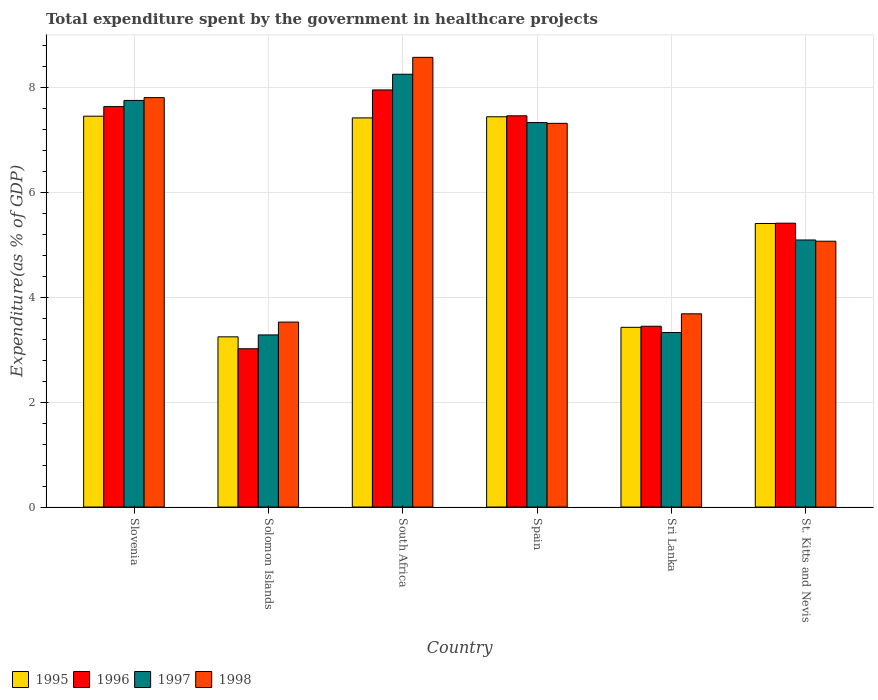How many bars are there on the 6th tick from the left?
Your answer should be very brief. 4. How many bars are there on the 6th tick from the right?
Provide a short and direct response. 4. What is the total expenditure spent by the government in healthcare projects in 1995 in St. Kitts and Nevis?
Provide a short and direct response. 5.41. Across all countries, what is the maximum total expenditure spent by the government in healthcare projects in 1997?
Your answer should be very brief. 8.26. Across all countries, what is the minimum total expenditure spent by the government in healthcare projects in 1996?
Offer a terse response. 3.02. In which country was the total expenditure spent by the government in healthcare projects in 1997 maximum?
Keep it short and to the point. South Africa. In which country was the total expenditure spent by the government in healthcare projects in 1998 minimum?
Your answer should be compact. Solomon Islands. What is the total total expenditure spent by the government in healthcare projects in 1997 in the graph?
Your answer should be very brief. 35.05. What is the difference between the total expenditure spent by the government in healthcare projects in 1997 in Solomon Islands and that in St. Kitts and Nevis?
Keep it short and to the point. -1.81. What is the difference between the total expenditure spent by the government in healthcare projects in 1996 in South Africa and the total expenditure spent by the government in healthcare projects in 1998 in Solomon Islands?
Provide a short and direct response. 4.43. What is the average total expenditure spent by the government in healthcare projects in 1996 per country?
Your answer should be very brief. 5.82. What is the difference between the total expenditure spent by the government in healthcare projects of/in 1995 and total expenditure spent by the government in healthcare projects of/in 1997 in Sri Lanka?
Make the answer very short. 0.1. In how many countries, is the total expenditure spent by the government in healthcare projects in 1998 greater than 0.8 %?
Your answer should be compact. 6. What is the ratio of the total expenditure spent by the government in healthcare projects in 1997 in South Africa to that in St. Kitts and Nevis?
Ensure brevity in your answer.  1.62. Is the total expenditure spent by the government in healthcare projects in 1997 in Slovenia less than that in South Africa?
Offer a terse response. Yes. What is the difference between the highest and the second highest total expenditure spent by the government in healthcare projects in 1996?
Your answer should be very brief. 0.18. What is the difference between the highest and the lowest total expenditure spent by the government in healthcare projects in 1995?
Offer a very short reply. 4.21. What does the 2nd bar from the right in St. Kitts and Nevis represents?
Provide a succinct answer. 1997. Is it the case that in every country, the sum of the total expenditure spent by the government in healthcare projects in 1998 and total expenditure spent by the government in healthcare projects in 1997 is greater than the total expenditure spent by the government in healthcare projects in 1995?
Your response must be concise. Yes. How many bars are there?
Make the answer very short. 24. How many countries are there in the graph?
Provide a succinct answer. 6. What is the difference between two consecutive major ticks on the Y-axis?
Make the answer very short. 2. Are the values on the major ticks of Y-axis written in scientific E-notation?
Your answer should be very brief. No. Does the graph contain any zero values?
Your answer should be very brief. No. Does the graph contain grids?
Your answer should be compact. Yes. Where does the legend appear in the graph?
Provide a succinct answer. Bottom left. How many legend labels are there?
Your answer should be compact. 4. How are the legend labels stacked?
Your answer should be compact. Horizontal. What is the title of the graph?
Your response must be concise. Total expenditure spent by the government in healthcare projects. What is the label or title of the Y-axis?
Your answer should be compact. Expenditure(as % of GDP). What is the Expenditure(as % of GDP) in 1995 in Slovenia?
Keep it short and to the point. 7.46. What is the Expenditure(as % of GDP) in 1996 in Slovenia?
Offer a very short reply. 7.64. What is the Expenditure(as % of GDP) in 1997 in Slovenia?
Offer a very short reply. 7.76. What is the Expenditure(as % of GDP) in 1998 in Slovenia?
Your response must be concise. 7.81. What is the Expenditure(as % of GDP) in 1995 in Solomon Islands?
Your response must be concise. 3.25. What is the Expenditure(as % of GDP) in 1996 in Solomon Islands?
Your answer should be compact. 3.02. What is the Expenditure(as % of GDP) of 1997 in Solomon Islands?
Keep it short and to the point. 3.28. What is the Expenditure(as % of GDP) in 1998 in Solomon Islands?
Your answer should be very brief. 3.53. What is the Expenditure(as % of GDP) of 1995 in South Africa?
Ensure brevity in your answer.  7.42. What is the Expenditure(as % of GDP) of 1996 in South Africa?
Provide a short and direct response. 7.96. What is the Expenditure(as % of GDP) of 1997 in South Africa?
Your response must be concise. 8.26. What is the Expenditure(as % of GDP) in 1998 in South Africa?
Your answer should be compact. 8.58. What is the Expenditure(as % of GDP) of 1995 in Spain?
Keep it short and to the point. 7.44. What is the Expenditure(as % of GDP) in 1996 in Spain?
Offer a very short reply. 7.46. What is the Expenditure(as % of GDP) in 1997 in Spain?
Your answer should be very brief. 7.33. What is the Expenditure(as % of GDP) in 1998 in Spain?
Your answer should be compact. 7.32. What is the Expenditure(as % of GDP) of 1995 in Sri Lanka?
Your answer should be compact. 3.43. What is the Expenditure(as % of GDP) of 1996 in Sri Lanka?
Your response must be concise. 3.45. What is the Expenditure(as % of GDP) in 1997 in Sri Lanka?
Your response must be concise. 3.33. What is the Expenditure(as % of GDP) in 1998 in Sri Lanka?
Offer a very short reply. 3.69. What is the Expenditure(as % of GDP) of 1995 in St. Kitts and Nevis?
Make the answer very short. 5.41. What is the Expenditure(as % of GDP) of 1996 in St. Kitts and Nevis?
Your response must be concise. 5.41. What is the Expenditure(as % of GDP) in 1997 in St. Kitts and Nevis?
Keep it short and to the point. 5.09. What is the Expenditure(as % of GDP) in 1998 in St. Kitts and Nevis?
Give a very brief answer. 5.07. Across all countries, what is the maximum Expenditure(as % of GDP) in 1995?
Make the answer very short. 7.46. Across all countries, what is the maximum Expenditure(as % of GDP) of 1996?
Keep it short and to the point. 7.96. Across all countries, what is the maximum Expenditure(as % of GDP) of 1997?
Your response must be concise. 8.26. Across all countries, what is the maximum Expenditure(as % of GDP) of 1998?
Your answer should be compact. 8.58. Across all countries, what is the minimum Expenditure(as % of GDP) in 1995?
Your response must be concise. 3.25. Across all countries, what is the minimum Expenditure(as % of GDP) of 1996?
Provide a succinct answer. 3.02. Across all countries, what is the minimum Expenditure(as % of GDP) of 1997?
Your answer should be compact. 3.28. Across all countries, what is the minimum Expenditure(as % of GDP) of 1998?
Provide a succinct answer. 3.53. What is the total Expenditure(as % of GDP) of 1995 in the graph?
Offer a very short reply. 34.41. What is the total Expenditure(as % of GDP) in 1996 in the graph?
Your answer should be compact. 34.94. What is the total Expenditure(as % of GDP) in 1997 in the graph?
Make the answer very short. 35.05. What is the total Expenditure(as % of GDP) of 1998 in the graph?
Offer a very short reply. 35.99. What is the difference between the Expenditure(as % of GDP) of 1995 in Slovenia and that in Solomon Islands?
Offer a very short reply. 4.21. What is the difference between the Expenditure(as % of GDP) of 1996 in Slovenia and that in Solomon Islands?
Offer a terse response. 4.62. What is the difference between the Expenditure(as % of GDP) of 1997 in Slovenia and that in Solomon Islands?
Provide a succinct answer. 4.47. What is the difference between the Expenditure(as % of GDP) of 1998 in Slovenia and that in Solomon Islands?
Your response must be concise. 4.28. What is the difference between the Expenditure(as % of GDP) in 1995 in Slovenia and that in South Africa?
Keep it short and to the point. 0.03. What is the difference between the Expenditure(as % of GDP) of 1996 in Slovenia and that in South Africa?
Make the answer very short. -0.32. What is the difference between the Expenditure(as % of GDP) of 1997 in Slovenia and that in South Africa?
Provide a short and direct response. -0.5. What is the difference between the Expenditure(as % of GDP) in 1998 in Slovenia and that in South Africa?
Ensure brevity in your answer.  -0.77. What is the difference between the Expenditure(as % of GDP) in 1995 in Slovenia and that in Spain?
Your response must be concise. 0.01. What is the difference between the Expenditure(as % of GDP) of 1996 in Slovenia and that in Spain?
Your answer should be compact. 0.18. What is the difference between the Expenditure(as % of GDP) of 1997 in Slovenia and that in Spain?
Keep it short and to the point. 0.42. What is the difference between the Expenditure(as % of GDP) of 1998 in Slovenia and that in Spain?
Ensure brevity in your answer.  0.49. What is the difference between the Expenditure(as % of GDP) of 1995 in Slovenia and that in Sri Lanka?
Offer a terse response. 4.03. What is the difference between the Expenditure(as % of GDP) of 1996 in Slovenia and that in Sri Lanka?
Your answer should be very brief. 4.19. What is the difference between the Expenditure(as % of GDP) of 1997 in Slovenia and that in Sri Lanka?
Your answer should be very brief. 4.43. What is the difference between the Expenditure(as % of GDP) of 1998 in Slovenia and that in Sri Lanka?
Your answer should be very brief. 4.12. What is the difference between the Expenditure(as % of GDP) in 1995 in Slovenia and that in St. Kitts and Nevis?
Offer a terse response. 2.05. What is the difference between the Expenditure(as % of GDP) of 1996 in Slovenia and that in St. Kitts and Nevis?
Provide a succinct answer. 2.22. What is the difference between the Expenditure(as % of GDP) in 1997 in Slovenia and that in St. Kitts and Nevis?
Make the answer very short. 2.66. What is the difference between the Expenditure(as % of GDP) in 1998 in Slovenia and that in St. Kitts and Nevis?
Your answer should be compact. 2.74. What is the difference between the Expenditure(as % of GDP) in 1995 in Solomon Islands and that in South Africa?
Provide a succinct answer. -4.18. What is the difference between the Expenditure(as % of GDP) in 1996 in Solomon Islands and that in South Africa?
Your answer should be very brief. -4.94. What is the difference between the Expenditure(as % of GDP) of 1997 in Solomon Islands and that in South Africa?
Provide a succinct answer. -4.97. What is the difference between the Expenditure(as % of GDP) of 1998 in Solomon Islands and that in South Africa?
Give a very brief answer. -5.05. What is the difference between the Expenditure(as % of GDP) in 1995 in Solomon Islands and that in Spain?
Provide a succinct answer. -4.2. What is the difference between the Expenditure(as % of GDP) of 1996 in Solomon Islands and that in Spain?
Give a very brief answer. -4.44. What is the difference between the Expenditure(as % of GDP) in 1997 in Solomon Islands and that in Spain?
Make the answer very short. -4.05. What is the difference between the Expenditure(as % of GDP) in 1998 in Solomon Islands and that in Spain?
Give a very brief answer. -3.79. What is the difference between the Expenditure(as % of GDP) in 1995 in Solomon Islands and that in Sri Lanka?
Keep it short and to the point. -0.18. What is the difference between the Expenditure(as % of GDP) in 1996 in Solomon Islands and that in Sri Lanka?
Keep it short and to the point. -0.43. What is the difference between the Expenditure(as % of GDP) in 1997 in Solomon Islands and that in Sri Lanka?
Keep it short and to the point. -0.05. What is the difference between the Expenditure(as % of GDP) of 1998 in Solomon Islands and that in Sri Lanka?
Offer a terse response. -0.16. What is the difference between the Expenditure(as % of GDP) of 1995 in Solomon Islands and that in St. Kitts and Nevis?
Offer a very short reply. -2.16. What is the difference between the Expenditure(as % of GDP) of 1996 in Solomon Islands and that in St. Kitts and Nevis?
Provide a short and direct response. -2.4. What is the difference between the Expenditure(as % of GDP) in 1997 in Solomon Islands and that in St. Kitts and Nevis?
Your answer should be very brief. -1.81. What is the difference between the Expenditure(as % of GDP) in 1998 in Solomon Islands and that in St. Kitts and Nevis?
Give a very brief answer. -1.54. What is the difference between the Expenditure(as % of GDP) in 1995 in South Africa and that in Spain?
Offer a terse response. -0.02. What is the difference between the Expenditure(as % of GDP) in 1996 in South Africa and that in Spain?
Provide a succinct answer. 0.49. What is the difference between the Expenditure(as % of GDP) of 1997 in South Africa and that in Spain?
Keep it short and to the point. 0.92. What is the difference between the Expenditure(as % of GDP) in 1998 in South Africa and that in Spain?
Offer a very short reply. 1.26. What is the difference between the Expenditure(as % of GDP) of 1995 in South Africa and that in Sri Lanka?
Your answer should be very brief. 3.99. What is the difference between the Expenditure(as % of GDP) in 1996 in South Africa and that in Sri Lanka?
Your response must be concise. 4.51. What is the difference between the Expenditure(as % of GDP) of 1997 in South Africa and that in Sri Lanka?
Provide a short and direct response. 4.93. What is the difference between the Expenditure(as % of GDP) in 1998 in South Africa and that in Sri Lanka?
Keep it short and to the point. 4.89. What is the difference between the Expenditure(as % of GDP) in 1995 in South Africa and that in St. Kitts and Nevis?
Make the answer very short. 2.01. What is the difference between the Expenditure(as % of GDP) of 1996 in South Africa and that in St. Kitts and Nevis?
Give a very brief answer. 2.54. What is the difference between the Expenditure(as % of GDP) in 1997 in South Africa and that in St. Kitts and Nevis?
Make the answer very short. 3.16. What is the difference between the Expenditure(as % of GDP) of 1998 in South Africa and that in St. Kitts and Nevis?
Offer a terse response. 3.51. What is the difference between the Expenditure(as % of GDP) of 1995 in Spain and that in Sri Lanka?
Your answer should be very brief. 4.02. What is the difference between the Expenditure(as % of GDP) in 1996 in Spain and that in Sri Lanka?
Make the answer very short. 4.01. What is the difference between the Expenditure(as % of GDP) in 1997 in Spain and that in Sri Lanka?
Ensure brevity in your answer.  4. What is the difference between the Expenditure(as % of GDP) of 1998 in Spain and that in Sri Lanka?
Your answer should be very brief. 3.63. What is the difference between the Expenditure(as % of GDP) of 1995 in Spain and that in St. Kitts and Nevis?
Offer a very short reply. 2.04. What is the difference between the Expenditure(as % of GDP) of 1996 in Spain and that in St. Kitts and Nevis?
Your answer should be very brief. 2.05. What is the difference between the Expenditure(as % of GDP) in 1997 in Spain and that in St. Kitts and Nevis?
Your answer should be very brief. 2.24. What is the difference between the Expenditure(as % of GDP) of 1998 in Spain and that in St. Kitts and Nevis?
Offer a very short reply. 2.25. What is the difference between the Expenditure(as % of GDP) in 1995 in Sri Lanka and that in St. Kitts and Nevis?
Give a very brief answer. -1.98. What is the difference between the Expenditure(as % of GDP) of 1996 in Sri Lanka and that in St. Kitts and Nevis?
Keep it short and to the point. -1.97. What is the difference between the Expenditure(as % of GDP) of 1997 in Sri Lanka and that in St. Kitts and Nevis?
Provide a short and direct response. -1.76. What is the difference between the Expenditure(as % of GDP) in 1998 in Sri Lanka and that in St. Kitts and Nevis?
Provide a succinct answer. -1.39. What is the difference between the Expenditure(as % of GDP) of 1995 in Slovenia and the Expenditure(as % of GDP) of 1996 in Solomon Islands?
Your answer should be very brief. 4.44. What is the difference between the Expenditure(as % of GDP) in 1995 in Slovenia and the Expenditure(as % of GDP) in 1997 in Solomon Islands?
Provide a short and direct response. 4.17. What is the difference between the Expenditure(as % of GDP) in 1995 in Slovenia and the Expenditure(as % of GDP) in 1998 in Solomon Islands?
Your answer should be compact. 3.93. What is the difference between the Expenditure(as % of GDP) in 1996 in Slovenia and the Expenditure(as % of GDP) in 1997 in Solomon Islands?
Your answer should be very brief. 4.36. What is the difference between the Expenditure(as % of GDP) in 1996 in Slovenia and the Expenditure(as % of GDP) in 1998 in Solomon Islands?
Give a very brief answer. 4.11. What is the difference between the Expenditure(as % of GDP) in 1997 in Slovenia and the Expenditure(as % of GDP) in 1998 in Solomon Islands?
Your answer should be very brief. 4.23. What is the difference between the Expenditure(as % of GDP) of 1995 in Slovenia and the Expenditure(as % of GDP) of 1996 in South Africa?
Your answer should be compact. -0.5. What is the difference between the Expenditure(as % of GDP) of 1995 in Slovenia and the Expenditure(as % of GDP) of 1997 in South Africa?
Provide a short and direct response. -0.8. What is the difference between the Expenditure(as % of GDP) of 1995 in Slovenia and the Expenditure(as % of GDP) of 1998 in South Africa?
Provide a succinct answer. -1.12. What is the difference between the Expenditure(as % of GDP) of 1996 in Slovenia and the Expenditure(as % of GDP) of 1997 in South Africa?
Your response must be concise. -0.62. What is the difference between the Expenditure(as % of GDP) in 1996 in Slovenia and the Expenditure(as % of GDP) in 1998 in South Africa?
Keep it short and to the point. -0.94. What is the difference between the Expenditure(as % of GDP) in 1997 in Slovenia and the Expenditure(as % of GDP) in 1998 in South Africa?
Your answer should be compact. -0.82. What is the difference between the Expenditure(as % of GDP) of 1995 in Slovenia and the Expenditure(as % of GDP) of 1996 in Spain?
Provide a short and direct response. -0.01. What is the difference between the Expenditure(as % of GDP) of 1995 in Slovenia and the Expenditure(as % of GDP) of 1997 in Spain?
Give a very brief answer. 0.12. What is the difference between the Expenditure(as % of GDP) in 1995 in Slovenia and the Expenditure(as % of GDP) in 1998 in Spain?
Your response must be concise. 0.14. What is the difference between the Expenditure(as % of GDP) in 1996 in Slovenia and the Expenditure(as % of GDP) in 1997 in Spain?
Your answer should be compact. 0.3. What is the difference between the Expenditure(as % of GDP) in 1996 in Slovenia and the Expenditure(as % of GDP) in 1998 in Spain?
Your answer should be compact. 0.32. What is the difference between the Expenditure(as % of GDP) of 1997 in Slovenia and the Expenditure(as % of GDP) of 1998 in Spain?
Provide a short and direct response. 0.44. What is the difference between the Expenditure(as % of GDP) of 1995 in Slovenia and the Expenditure(as % of GDP) of 1996 in Sri Lanka?
Offer a very short reply. 4.01. What is the difference between the Expenditure(as % of GDP) in 1995 in Slovenia and the Expenditure(as % of GDP) in 1997 in Sri Lanka?
Ensure brevity in your answer.  4.13. What is the difference between the Expenditure(as % of GDP) in 1995 in Slovenia and the Expenditure(as % of GDP) in 1998 in Sri Lanka?
Give a very brief answer. 3.77. What is the difference between the Expenditure(as % of GDP) of 1996 in Slovenia and the Expenditure(as % of GDP) of 1997 in Sri Lanka?
Give a very brief answer. 4.31. What is the difference between the Expenditure(as % of GDP) of 1996 in Slovenia and the Expenditure(as % of GDP) of 1998 in Sri Lanka?
Keep it short and to the point. 3.95. What is the difference between the Expenditure(as % of GDP) of 1997 in Slovenia and the Expenditure(as % of GDP) of 1998 in Sri Lanka?
Your response must be concise. 4.07. What is the difference between the Expenditure(as % of GDP) in 1995 in Slovenia and the Expenditure(as % of GDP) in 1996 in St. Kitts and Nevis?
Your answer should be compact. 2.04. What is the difference between the Expenditure(as % of GDP) of 1995 in Slovenia and the Expenditure(as % of GDP) of 1997 in St. Kitts and Nevis?
Offer a very short reply. 2.36. What is the difference between the Expenditure(as % of GDP) of 1995 in Slovenia and the Expenditure(as % of GDP) of 1998 in St. Kitts and Nevis?
Your response must be concise. 2.38. What is the difference between the Expenditure(as % of GDP) in 1996 in Slovenia and the Expenditure(as % of GDP) in 1997 in St. Kitts and Nevis?
Your response must be concise. 2.54. What is the difference between the Expenditure(as % of GDP) in 1996 in Slovenia and the Expenditure(as % of GDP) in 1998 in St. Kitts and Nevis?
Offer a very short reply. 2.57. What is the difference between the Expenditure(as % of GDP) in 1997 in Slovenia and the Expenditure(as % of GDP) in 1998 in St. Kitts and Nevis?
Keep it short and to the point. 2.69. What is the difference between the Expenditure(as % of GDP) of 1995 in Solomon Islands and the Expenditure(as % of GDP) of 1996 in South Africa?
Offer a very short reply. -4.71. What is the difference between the Expenditure(as % of GDP) of 1995 in Solomon Islands and the Expenditure(as % of GDP) of 1997 in South Africa?
Offer a terse response. -5.01. What is the difference between the Expenditure(as % of GDP) of 1995 in Solomon Islands and the Expenditure(as % of GDP) of 1998 in South Africa?
Offer a very short reply. -5.33. What is the difference between the Expenditure(as % of GDP) of 1996 in Solomon Islands and the Expenditure(as % of GDP) of 1997 in South Africa?
Offer a very short reply. -5.24. What is the difference between the Expenditure(as % of GDP) of 1996 in Solomon Islands and the Expenditure(as % of GDP) of 1998 in South Africa?
Provide a short and direct response. -5.56. What is the difference between the Expenditure(as % of GDP) in 1997 in Solomon Islands and the Expenditure(as % of GDP) in 1998 in South Africa?
Ensure brevity in your answer.  -5.29. What is the difference between the Expenditure(as % of GDP) in 1995 in Solomon Islands and the Expenditure(as % of GDP) in 1996 in Spain?
Your response must be concise. -4.22. What is the difference between the Expenditure(as % of GDP) of 1995 in Solomon Islands and the Expenditure(as % of GDP) of 1997 in Spain?
Provide a short and direct response. -4.09. What is the difference between the Expenditure(as % of GDP) in 1995 in Solomon Islands and the Expenditure(as % of GDP) in 1998 in Spain?
Make the answer very short. -4.07. What is the difference between the Expenditure(as % of GDP) of 1996 in Solomon Islands and the Expenditure(as % of GDP) of 1997 in Spain?
Your answer should be compact. -4.31. What is the difference between the Expenditure(as % of GDP) of 1996 in Solomon Islands and the Expenditure(as % of GDP) of 1998 in Spain?
Offer a very short reply. -4.3. What is the difference between the Expenditure(as % of GDP) in 1997 in Solomon Islands and the Expenditure(as % of GDP) in 1998 in Spain?
Offer a very short reply. -4.04. What is the difference between the Expenditure(as % of GDP) in 1995 in Solomon Islands and the Expenditure(as % of GDP) in 1996 in Sri Lanka?
Your answer should be very brief. -0.2. What is the difference between the Expenditure(as % of GDP) of 1995 in Solomon Islands and the Expenditure(as % of GDP) of 1997 in Sri Lanka?
Provide a succinct answer. -0.08. What is the difference between the Expenditure(as % of GDP) in 1995 in Solomon Islands and the Expenditure(as % of GDP) in 1998 in Sri Lanka?
Offer a very short reply. -0.44. What is the difference between the Expenditure(as % of GDP) in 1996 in Solomon Islands and the Expenditure(as % of GDP) in 1997 in Sri Lanka?
Offer a very short reply. -0.31. What is the difference between the Expenditure(as % of GDP) of 1996 in Solomon Islands and the Expenditure(as % of GDP) of 1998 in Sri Lanka?
Your response must be concise. -0.67. What is the difference between the Expenditure(as % of GDP) in 1997 in Solomon Islands and the Expenditure(as % of GDP) in 1998 in Sri Lanka?
Offer a terse response. -0.4. What is the difference between the Expenditure(as % of GDP) of 1995 in Solomon Islands and the Expenditure(as % of GDP) of 1996 in St. Kitts and Nevis?
Provide a succinct answer. -2.17. What is the difference between the Expenditure(as % of GDP) of 1995 in Solomon Islands and the Expenditure(as % of GDP) of 1997 in St. Kitts and Nevis?
Your answer should be very brief. -1.85. What is the difference between the Expenditure(as % of GDP) of 1995 in Solomon Islands and the Expenditure(as % of GDP) of 1998 in St. Kitts and Nevis?
Offer a very short reply. -1.82. What is the difference between the Expenditure(as % of GDP) in 1996 in Solomon Islands and the Expenditure(as % of GDP) in 1997 in St. Kitts and Nevis?
Ensure brevity in your answer.  -2.07. What is the difference between the Expenditure(as % of GDP) of 1996 in Solomon Islands and the Expenditure(as % of GDP) of 1998 in St. Kitts and Nevis?
Provide a short and direct response. -2.05. What is the difference between the Expenditure(as % of GDP) of 1997 in Solomon Islands and the Expenditure(as % of GDP) of 1998 in St. Kitts and Nevis?
Your answer should be compact. -1.79. What is the difference between the Expenditure(as % of GDP) in 1995 in South Africa and the Expenditure(as % of GDP) in 1996 in Spain?
Ensure brevity in your answer.  -0.04. What is the difference between the Expenditure(as % of GDP) in 1995 in South Africa and the Expenditure(as % of GDP) in 1997 in Spain?
Your response must be concise. 0.09. What is the difference between the Expenditure(as % of GDP) in 1995 in South Africa and the Expenditure(as % of GDP) in 1998 in Spain?
Offer a terse response. 0.1. What is the difference between the Expenditure(as % of GDP) of 1996 in South Africa and the Expenditure(as % of GDP) of 1997 in Spain?
Make the answer very short. 0.62. What is the difference between the Expenditure(as % of GDP) of 1996 in South Africa and the Expenditure(as % of GDP) of 1998 in Spain?
Make the answer very short. 0.64. What is the difference between the Expenditure(as % of GDP) in 1997 in South Africa and the Expenditure(as % of GDP) in 1998 in Spain?
Provide a succinct answer. 0.94. What is the difference between the Expenditure(as % of GDP) in 1995 in South Africa and the Expenditure(as % of GDP) in 1996 in Sri Lanka?
Make the answer very short. 3.97. What is the difference between the Expenditure(as % of GDP) of 1995 in South Africa and the Expenditure(as % of GDP) of 1997 in Sri Lanka?
Offer a very short reply. 4.09. What is the difference between the Expenditure(as % of GDP) in 1995 in South Africa and the Expenditure(as % of GDP) in 1998 in Sri Lanka?
Provide a succinct answer. 3.74. What is the difference between the Expenditure(as % of GDP) of 1996 in South Africa and the Expenditure(as % of GDP) of 1997 in Sri Lanka?
Provide a short and direct response. 4.63. What is the difference between the Expenditure(as % of GDP) of 1996 in South Africa and the Expenditure(as % of GDP) of 1998 in Sri Lanka?
Keep it short and to the point. 4.27. What is the difference between the Expenditure(as % of GDP) in 1997 in South Africa and the Expenditure(as % of GDP) in 1998 in Sri Lanka?
Make the answer very short. 4.57. What is the difference between the Expenditure(as % of GDP) in 1995 in South Africa and the Expenditure(as % of GDP) in 1996 in St. Kitts and Nevis?
Offer a terse response. 2.01. What is the difference between the Expenditure(as % of GDP) of 1995 in South Africa and the Expenditure(as % of GDP) of 1997 in St. Kitts and Nevis?
Your answer should be compact. 2.33. What is the difference between the Expenditure(as % of GDP) of 1995 in South Africa and the Expenditure(as % of GDP) of 1998 in St. Kitts and Nevis?
Provide a succinct answer. 2.35. What is the difference between the Expenditure(as % of GDP) of 1996 in South Africa and the Expenditure(as % of GDP) of 1997 in St. Kitts and Nevis?
Offer a very short reply. 2.86. What is the difference between the Expenditure(as % of GDP) of 1996 in South Africa and the Expenditure(as % of GDP) of 1998 in St. Kitts and Nevis?
Make the answer very short. 2.89. What is the difference between the Expenditure(as % of GDP) in 1997 in South Africa and the Expenditure(as % of GDP) in 1998 in St. Kitts and Nevis?
Your response must be concise. 3.18. What is the difference between the Expenditure(as % of GDP) of 1995 in Spain and the Expenditure(as % of GDP) of 1996 in Sri Lanka?
Your response must be concise. 4. What is the difference between the Expenditure(as % of GDP) of 1995 in Spain and the Expenditure(as % of GDP) of 1997 in Sri Lanka?
Offer a very short reply. 4.11. What is the difference between the Expenditure(as % of GDP) in 1995 in Spain and the Expenditure(as % of GDP) in 1998 in Sri Lanka?
Make the answer very short. 3.76. What is the difference between the Expenditure(as % of GDP) of 1996 in Spain and the Expenditure(as % of GDP) of 1997 in Sri Lanka?
Your answer should be very brief. 4.13. What is the difference between the Expenditure(as % of GDP) of 1996 in Spain and the Expenditure(as % of GDP) of 1998 in Sri Lanka?
Offer a very short reply. 3.78. What is the difference between the Expenditure(as % of GDP) of 1997 in Spain and the Expenditure(as % of GDP) of 1998 in Sri Lanka?
Provide a short and direct response. 3.65. What is the difference between the Expenditure(as % of GDP) in 1995 in Spain and the Expenditure(as % of GDP) in 1996 in St. Kitts and Nevis?
Offer a terse response. 2.03. What is the difference between the Expenditure(as % of GDP) in 1995 in Spain and the Expenditure(as % of GDP) in 1997 in St. Kitts and Nevis?
Keep it short and to the point. 2.35. What is the difference between the Expenditure(as % of GDP) of 1995 in Spain and the Expenditure(as % of GDP) of 1998 in St. Kitts and Nevis?
Provide a succinct answer. 2.37. What is the difference between the Expenditure(as % of GDP) in 1996 in Spain and the Expenditure(as % of GDP) in 1997 in St. Kitts and Nevis?
Provide a short and direct response. 2.37. What is the difference between the Expenditure(as % of GDP) of 1996 in Spain and the Expenditure(as % of GDP) of 1998 in St. Kitts and Nevis?
Ensure brevity in your answer.  2.39. What is the difference between the Expenditure(as % of GDP) of 1997 in Spain and the Expenditure(as % of GDP) of 1998 in St. Kitts and Nevis?
Offer a terse response. 2.26. What is the difference between the Expenditure(as % of GDP) of 1995 in Sri Lanka and the Expenditure(as % of GDP) of 1996 in St. Kitts and Nevis?
Offer a terse response. -1.99. What is the difference between the Expenditure(as % of GDP) of 1995 in Sri Lanka and the Expenditure(as % of GDP) of 1997 in St. Kitts and Nevis?
Your response must be concise. -1.67. What is the difference between the Expenditure(as % of GDP) of 1995 in Sri Lanka and the Expenditure(as % of GDP) of 1998 in St. Kitts and Nevis?
Your answer should be compact. -1.64. What is the difference between the Expenditure(as % of GDP) of 1996 in Sri Lanka and the Expenditure(as % of GDP) of 1997 in St. Kitts and Nevis?
Give a very brief answer. -1.65. What is the difference between the Expenditure(as % of GDP) of 1996 in Sri Lanka and the Expenditure(as % of GDP) of 1998 in St. Kitts and Nevis?
Offer a very short reply. -1.62. What is the difference between the Expenditure(as % of GDP) in 1997 in Sri Lanka and the Expenditure(as % of GDP) in 1998 in St. Kitts and Nevis?
Your response must be concise. -1.74. What is the average Expenditure(as % of GDP) of 1995 per country?
Your answer should be compact. 5.73. What is the average Expenditure(as % of GDP) of 1996 per country?
Make the answer very short. 5.82. What is the average Expenditure(as % of GDP) of 1997 per country?
Your response must be concise. 5.84. What is the average Expenditure(as % of GDP) in 1998 per country?
Your response must be concise. 6. What is the difference between the Expenditure(as % of GDP) of 1995 and Expenditure(as % of GDP) of 1996 in Slovenia?
Offer a very short reply. -0.18. What is the difference between the Expenditure(as % of GDP) in 1995 and Expenditure(as % of GDP) in 1997 in Slovenia?
Provide a short and direct response. -0.3. What is the difference between the Expenditure(as % of GDP) in 1995 and Expenditure(as % of GDP) in 1998 in Slovenia?
Your response must be concise. -0.35. What is the difference between the Expenditure(as % of GDP) of 1996 and Expenditure(as % of GDP) of 1997 in Slovenia?
Ensure brevity in your answer.  -0.12. What is the difference between the Expenditure(as % of GDP) of 1996 and Expenditure(as % of GDP) of 1998 in Slovenia?
Keep it short and to the point. -0.17. What is the difference between the Expenditure(as % of GDP) of 1997 and Expenditure(as % of GDP) of 1998 in Slovenia?
Make the answer very short. -0.05. What is the difference between the Expenditure(as % of GDP) in 1995 and Expenditure(as % of GDP) in 1996 in Solomon Islands?
Ensure brevity in your answer.  0.23. What is the difference between the Expenditure(as % of GDP) in 1995 and Expenditure(as % of GDP) in 1997 in Solomon Islands?
Offer a very short reply. -0.04. What is the difference between the Expenditure(as % of GDP) of 1995 and Expenditure(as % of GDP) of 1998 in Solomon Islands?
Your answer should be very brief. -0.28. What is the difference between the Expenditure(as % of GDP) in 1996 and Expenditure(as % of GDP) in 1997 in Solomon Islands?
Ensure brevity in your answer.  -0.26. What is the difference between the Expenditure(as % of GDP) of 1996 and Expenditure(as % of GDP) of 1998 in Solomon Islands?
Offer a terse response. -0.51. What is the difference between the Expenditure(as % of GDP) of 1997 and Expenditure(as % of GDP) of 1998 in Solomon Islands?
Provide a short and direct response. -0.24. What is the difference between the Expenditure(as % of GDP) of 1995 and Expenditure(as % of GDP) of 1996 in South Africa?
Give a very brief answer. -0.53. What is the difference between the Expenditure(as % of GDP) in 1995 and Expenditure(as % of GDP) in 1997 in South Africa?
Give a very brief answer. -0.83. What is the difference between the Expenditure(as % of GDP) of 1995 and Expenditure(as % of GDP) of 1998 in South Africa?
Offer a very short reply. -1.15. What is the difference between the Expenditure(as % of GDP) in 1996 and Expenditure(as % of GDP) in 1997 in South Africa?
Your answer should be compact. -0.3. What is the difference between the Expenditure(as % of GDP) in 1996 and Expenditure(as % of GDP) in 1998 in South Africa?
Your response must be concise. -0.62. What is the difference between the Expenditure(as % of GDP) of 1997 and Expenditure(as % of GDP) of 1998 in South Africa?
Ensure brevity in your answer.  -0.32. What is the difference between the Expenditure(as % of GDP) in 1995 and Expenditure(as % of GDP) in 1996 in Spain?
Provide a short and direct response. -0.02. What is the difference between the Expenditure(as % of GDP) in 1995 and Expenditure(as % of GDP) in 1997 in Spain?
Your response must be concise. 0.11. What is the difference between the Expenditure(as % of GDP) of 1995 and Expenditure(as % of GDP) of 1998 in Spain?
Your answer should be very brief. 0.13. What is the difference between the Expenditure(as % of GDP) in 1996 and Expenditure(as % of GDP) in 1997 in Spain?
Keep it short and to the point. 0.13. What is the difference between the Expenditure(as % of GDP) in 1996 and Expenditure(as % of GDP) in 1998 in Spain?
Offer a terse response. 0.14. What is the difference between the Expenditure(as % of GDP) of 1997 and Expenditure(as % of GDP) of 1998 in Spain?
Offer a terse response. 0.01. What is the difference between the Expenditure(as % of GDP) of 1995 and Expenditure(as % of GDP) of 1996 in Sri Lanka?
Ensure brevity in your answer.  -0.02. What is the difference between the Expenditure(as % of GDP) in 1995 and Expenditure(as % of GDP) in 1997 in Sri Lanka?
Your answer should be very brief. 0.1. What is the difference between the Expenditure(as % of GDP) of 1995 and Expenditure(as % of GDP) of 1998 in Sri Lanka?
Your answer should be compact. -0.26. What is the difference between the Expenditure(as % of GDP) in 1996 and Expenditure(as % of GDP) in 1997 in Sri Lanka?
Make the answer very short. 0.12. What is the difference between the Expenditure(as % of GDP) of 1996 and Expenditure(as % of GDP) of 1998 in Sri Lanka?
Offer a terse response. -0.24. What is the difference between the Expenditure(as % of GDP) in 1997 and Expenditure(as % of GDP) in 1998 in Sri Lanka?
Provide a short and direct response. -0.36. What is the difference between the Expenditure(as % of GDP) of 1995 and Expenditure(as % of GDP) of 1996 in St. Kitts and Nevis?
Your answer should be compact. -0.01. What is the difference between the Expenditure(as % of GDP) of 1995 and Expenditure(as % of GDP) of 1997 in St. Kitts and Nevis?
Make the answer very short. 0.32. What is the difference between the Expenditure(as % of GDP) in 1995 and Expenditure(as % of GDP) in 1998 in St. Kitts and Nevis?
Make the answer very short. 0.34. What is the difference between the Expenditure(as % of GDP) of 1996 and Expenditure(as % of GDP) of 1997 in St. Kitts and Nevis?
Make the answer very short. 0.32. What is the difference between the Expenditure(as % of GDP) in 1996 and Expenditure(as % of GDP) in 1998 in St. Kitts and Nevis?
Your response must be concise. 0.34. What is the difference between the Expenditure(as % of GDP) of 1997 and Expenditure(as % of GDP) of 1998 in St. Kitts and Nevis?
Make the answer very short. 0.02. What is the ratio of the Expenditure(as % of GDP) of 1995 in Slovenia to that in Solomon Islands?
Make the answer very short. 2.3. What is the ratio of the Expenditure(as % of GDP) in 1996 in Slovenia to that in Solomon Islands?
Provide a succinct answer. 2.53. What is the ratio of the Expenditure(as % of GDP) of 1997 in Slovenia to that in Solomon Islands?
Keep it short and to the point. 2.36. What is the ratio of the Expenditure(as % of GDP) in 1998 in Slovenia to that in Solomon Islands?
Provide a short and direct response. 2.21. What is the ratio of the Expenditure(as % of GDP) in 1996 in Slovenia to that in South Africa?
Give a very brief answer. 0.96. What is the ratio of the Expenditure(as % of GDP) of 1997 in Slovenia to that in South Africa?
Keep it short and to the point. 0.94. What is the ratio of the Expenditure(as % of GDP) of 1998 in Slovenia to that in South Africa?
Keep it short and to the point. 0.91. What is the ratio of the Expenditure(as % of GDP) in 1995 in Slovenia to that in Spain?
Make the answer very short. 1. What is the ratio of the Expenditure(as % of GDP) of 1996 in Slovenia to that in Spain?
Offer a very short reply. 1.02. What is the ratio of the Expenditure(as % of GDP) of 1997 in Slovenia to that in Spain?
Your response must be concise. 1.06. What is the ratio of the Expenditure(as % of GDP) of 1998 in Slovenia to that in Spain?
Make the answer very short. 1.07. What is the ratio of the Expenditure(as % of GDP) of 1995 in Slovenia to that in Sri Lanka?
Make the answer very short. 2.17. What is the ratio of the Expenditure(as % of GDP) of 1996 in Slovenia to that in Sri Lanka?
Make the answer very short. 2.21. What is the ratio of the Expenditure(as % of GDP) of 1997 in Slovenia to that in Sri Lanka?
Keep it short and to the point. 2.33. What is the ratio of the Expenditure(as % of GDP) of 1998 in Slovenia to that in Sri Lanka?
Your response must be concise. 2.12. What is the ratio of the Expenditure(as % of GDP) of 1995 in Slovenia to that in St. Kitts and Nevis?
Ensure brevity in your answer.  1.38. What is the ratio of the Expenditure(as % of GDP) in 1996 in Slovenia to that in St. Kitts and Nevis?
Your answer should be compact. 1.41. What is the ratio of the Expenditure(as % of GDP) in 1997 in Slovenia to that in St. Kitts and Nevis?
Make the answer very short. 1.52. What is the ratio of the Expenditure(as % of GDP) of 1998 in Slovenia to that in St. Kitts and Nevis?
Your answer should be very brief. 1.54. What is the ratio of the Expenditure(as % of GDP) in 1995 in Solomon Islands to that in South Africa?
Give a very brief answer. 0.44. What is the ratio of the Expenditure(as % of GDP) in 1996 in Solomon Islands to that in South Africa?
Offer a very short reply. 0.38. What is the ratio of the Expenditure(as % of GDP) in 1997 in Solomon Islands to that in South Africa?
Provide a succinct answer. 0.4. What is the ratio of the Expenditure(as % of GDP) of 1998 in Solomon Islands to that in South Africa?
Offer a terse response. 0.41. What is the ratio of the Expenditure(as % of GDP) of 1995 in Solomon Islands to that in Spain?
Your response must be concise. 0.44. What is the ratio of the Expenditure(as % of GDP) in 1996 in Solomon Islands to that in Spain?
Your answer should be compact. 0.4. What is the ratio of the Expenditure(as % of GDP) in 1997 in Solomon Islands to that in Spain?
Offer a very short reply. 0.45. What is the ratio of the Expenditure(as % of GDP) of 1998 in Solomon Islands to that in Spain?
Ensure brevity in your answer.  0.48. What is the ratio of the Expenditure(as % of GDP) in 1995 in Solomon Islands to that in Sri Lanka?
Offer a very short reply. 0.95. What is the ratio of the Expenditure(as % of GDP) in 1996 in Solomon Islands to that in Sri Lanka?
Your answer should be very brief. 0.88. What is the ratio of the Expenditure(as % of GDP) of 1997 in Solomon Islands to that in Sri Lanka?
Your response must be concise. 0.99. What is the ratio of the Expenditure(as % of GDP) in 1998 in Solomon Islands to that in Sri Lanka?
Offer a terse response. 0.96. What is the ratio of the Expenditure(as % of GDP) of 1995 in Solomon Islands to that in St. Kitts and Nevis?
Ensure brevity in your answer.  0.6. What is the ratio of the Expenditure(as % of GDP) of 1996 in Solomon Islands to that in St. Kitts and Nevis?
Make the answer very short. 0.56. What is the ratio of the Expenditure(as % of GDP) of 1997 in Solomon Islands to that in St. Kitts and Nevis?
Provide a succinct answer. 0.64. What is the ratio of the Expenditure(as % of GDP) of 1998 in Solomon Islands to that in St. Kitts and Nevis?
Offer a very short reply. 0.7. What is the ratio of the Expenditure(as % of GDP) in 1996 in South Africa to that in Spain?
Provide a succinct answer. 1.07. What is the ratio of the Expenditure(as % of GDP) in 1997 in South Africa to that in Spain?
Offer a terse response. 1.13. What is the ratio of the Expenditure(as % of GDP) in 1998 in South Africa to that in Spain?
Provide a short and direct response. 1.17. What is the ratio of the Expenditure(as % of GDP) of 1995 in South Africa to that in Sri Lanka?
Your answer should be very brief. 2.17. What is the ratio of the Expenditure(as % of GDP) of 1996 in South Africa to that in Sri Lanka?
Keep it short and to the point. 2.31. What is the ratio of the Expenditure(as % of GDP) in 1997 in South Africa to that in Sri Lanka?
Provide a succinct answer. 2.48. What is the ratio of the Expenditure(as % of GDP) of 1998 in South Africa to that in Sri Lanka?
Your answer should be compact. 2.33. What is the ratio of the Expenditure(as % of GDP) of 1995 in South Africa to that in St. Kitts and Nevis?
Make the answer very short. 1.37. What is the ratio of the Expenditure(as % of GDP) of 1996 in South Africa to that in St. Kitts and Nevis?
Provide a succinct answer. 1.47. What is the ratio of the Expenditure(as % of GDP) of 1997 in South Africa to that in St. Kitts and Nevis?
Keep it short and to the point. 1.62. What is the ratio of the Expenditure(as % of GDP) in 1998 in South Africa to that in St. Kitts and Nevis?
Make the answer very short. 1.69. What is the ratio of the Expenditure(as % of GDP) of 1995 in Spain to that in Sri Lanka?
Make the answer very short. 2.17. What is the ratio of the Expenditure(as % of GDP) of 1996 in Spain to that in Sri Lanka?
Make the answer very short. 2.16. What is the ratio of the Expenditure(as % of GDP) in 1997 in Spain to that in Sri Lanka?
Make the answer very short. 2.2. What is the ratio of the Expenditure(as % of GDP) in 1998 in Spain to that in Sri Lanka?
Your answer should be very brief. 1.99. What is the ratio of the Expenditure(as % of GDP) in 1995 in Spain to that in St. Kitts and Nevis?
Provide a short and direct response. 1.38. What is the ratio of the Expenditure(as % of GDP) in 1996 in Spain to that in St. Kitts and Nevis?
Provide a succinct answer. 1.38. What is the ratio of the Expenditure(as % of GDP) of 1997 in Spain to that in St. Kitts and Nevis?
Ensure brevity in your answer.  1.44. What is the ratio of the Expenditure(as % of GDP) of 1998 in Spain to that in St. Kitts and Nevis?
Ensure brevity in your answer.  1.44. What is the ratio of the Expenditure(as % of GDP) in 1995 in Sri Lanka to that in St. Kitts and Nevis?
Keep it short and to the point. 0.63. What is the ratio of the Expenditure(as % of GDP) in 1996 in Sri Lanka to that in St. Kitts and Nevis?
Provide a short and direct response. 0.64. What is the ratio of the Expenditure(as % of GDP) of 1997 in Sri Lanka to that in St. Kitts and Nevis?
Ensure brevity in your answer.  0.65. What is the ratio of the Expenditure(as % of GDP) in 1998 in Sri Lanka to that in St. Kitts and Nevis?
Ensure brevity in your answer.  0.73. What is the difference between the highest and the second highest Expenditure(as % of GDP) of 1995?
Provide a short and direct response. 0.01. What is the difference between the highest and the second highest Expenditure(as % of GDP) of 1996?
Your response must be concise. 0.32. What is the difference between the highest and the second highest Expenditure(as % of GDP) of 1997?
Make the answer very short. 0.5. What is the difference between the highest and the second highest Expenditure(as % of GDP) in 1998?
Provide a short and direct response. 0.77. What is the difference between the highest and the lowest Expenditure(as % of GDP) of 1995?
Your answer should be compact. 4.21. What is the difference between the highest and the lowest Expenditure(as % of GDP) of 1996?
Offer a very short reply. 4.94. What is the difference between the highest and the lowest Expenditure(as % of GDP) of 1997?
Offer a very short reply. 4.97. What is the difference between the highest and the lowest Expenditure(as % of GDP) of 1998?
Your answer should be very brief. 5.05. 